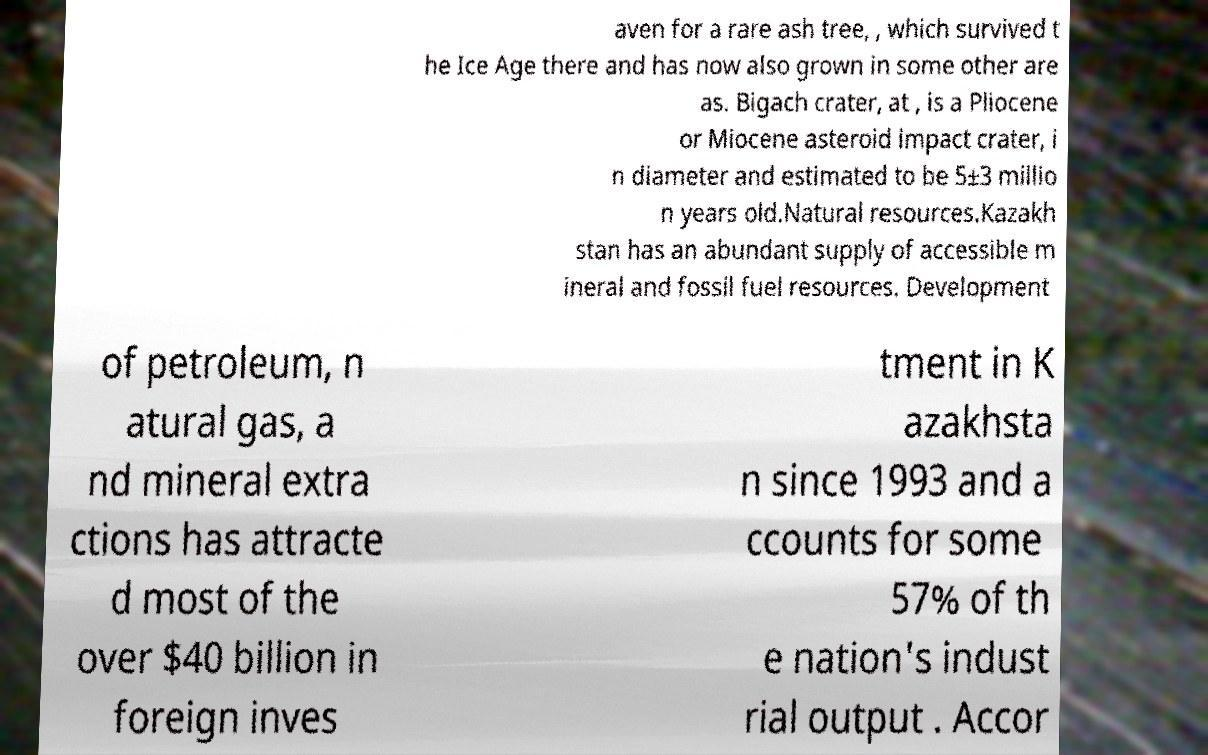Could you assist in decoding the text presented in this image and type it out clearly? aven for a rare ash tree, , which survived t he Ice Age there and has now also grown in some other are as. Bigach crater, at , is a Pliocene or Miocene asteroid impact crater, i n diameter and estimated to be 5±3 millio n years old.Natural resources.Kazakh stan has an abundant supply of accessible m ineral and fossil fuel resources. Development of petroleum, n atural gas, a nd mineral extra ctions has attracte d most of the over $40 billion in foreign inves tment in K azakhsta n since 1993 and a ccounts for some 57% of th e nation's indust rial output . Accor 